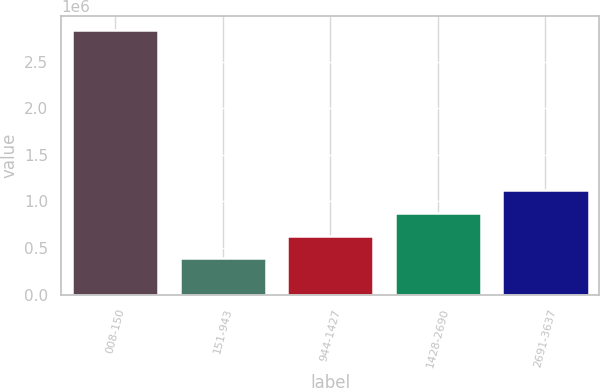<chart> <loc_0><loc_0><loc_500><loc_500><bar_chart><fcel>008-150<fcel>151-943<fcel>944-1427<fcel>1428-2690<fcel>2691-3637<nl><fcel>2.84296e+06<fcel>387172<fcel>632751<fcel>878329<fcel>1.12391e+06<nl></chart> 